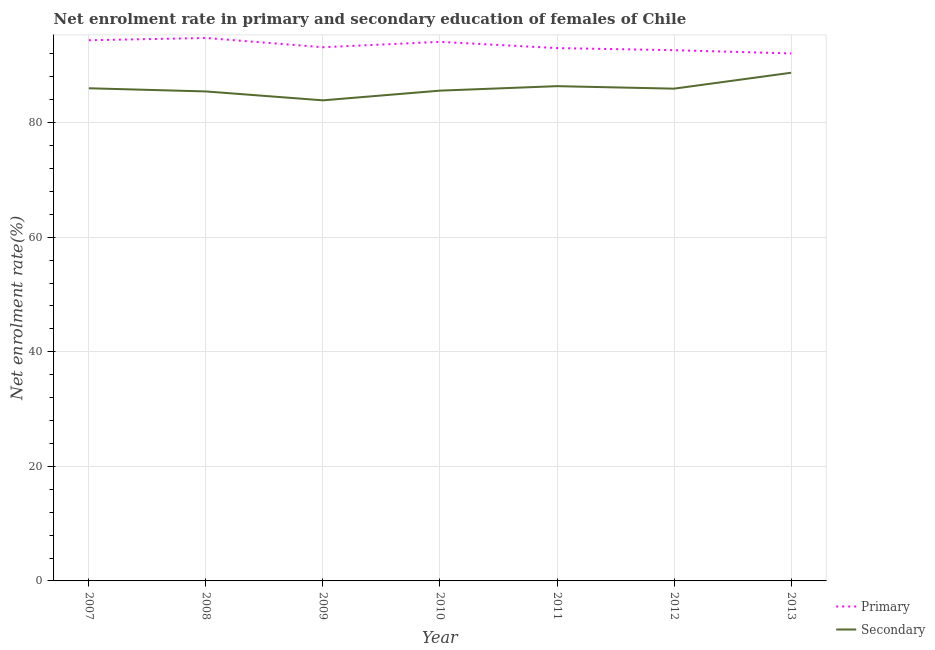Is the number of lines equal to the number of legend labels?
Ensure brevity in your answer.  Yes. What is the enrollment rate in secondary education in 2007?
Ensure brevity in your answer.  86. Across all years, what is the maximum enrollment rate in primary education?
Give a very brief answer. 94.77. Across all years, what is the minimum enrollment rate in primary education?
Provide a short and direct response. 92.08. What is the total enrollment rate in secondary education in the graph?
Your response must be concise. 601.92. What is the difference between the enrollment rate in secondary education in 2011 and that in 2012?
Your answer should be very brief. 0.44. What is the difference between the enrollment rate in secondary education in 2007 and the enrollment rate in primary education in 2013?
Give a very brief answer. -6.08. What is the average enrollment rate in secondary education per year?
Offer a terse response. 85.99. In the year 2013, what is the difference between the enrollment rate in primary education and enrollment rate in secondary education?
Ensure brevity in your answer.  3.37. What is the ratio of the enrollment rate in primary education in 2008 to that in 2012?
Offer a very short reply. 1.02. Is the difference between the enrollment rate in secondary education in 2009 and 2013 greater than the difference between the enrollment rate in primary education in 2009 and 2013?
Your answer should be compact. No. What is the difference between the highest and the second highest enrollment rate in primary education?
Offer a very short reply. 0.39. What is the difference between the highest and the lowest enrollment rate in secondary education?
Provide a short and direct response. 4.82. In how many years, is the enrollment rate in secondary education greater than the average enrollment rate in secondary education taken over all years?
Ensure brevity in your answer.  3. Is the enrollment rate in primary education strictly greater than the enrollment rate in secondary education over the years?
Provide a succinct answer. Yes. How many lines are there?
Offer a terse response. 2. How many years are there in the graph?
Give a very brief answer. 7. Are the values on the major ticks of Y-axis written in scientific E-notation?
Offer a terse response. No. Does the graph contain any zero values?
Make the answer very short. No. What is the title of the graph?
Your response must be concise. Net enrolment rate in primary and secondary education of females of Chile. Does "Registered firms" appear as one of the legend labels in the graph?
Offer a terse response. No. What is the label or title of the X-axis?
Give a very brief answer. Year. What is the label or title of the Y-axis?
Your answer should be very brief. Net enrolment rate(%). What is the Net enrolment rate(%) in Primary in 2007?
Give a very brief answer. 94.38. What is the Net enrolment rate(%) in Secondary in 2007?
Keep it short and to the point. 86. What is the Net enrolment rate(%) of Primary in 2008?
Provide a short and direct response. 94.77. What is the Net enrolment rate(%) of Secondary in 2008?
Your answer should be compact. 85.44. What is the Net enrolment rate(%) in Primary in 2009?
Your response must be concise. 93.16. What is the Net enrolment rate(%) in Secondary in 2009?
Your response must be concise. 83.89. What is the Net enrolment rate(%) of Primary in 2010?
Give a very brief answer. 94.1. What is the Net enrolment rate(%) in Secondary in 2010?
Give a very brief answer. 85.58. What is the Net enrolment rate(%) in Primary in 2011?
Give a very brief answer. 93.01. What is the Net enrolment rate(%) of Secondary in 2011?
Make the answer very short. 86.37. What is the Net enrolment rate(%) in Primary in 2012?
Provide a short and direct response. 92.65. What is the Net enrolment rate(%) in Secondary in 2012?
Ensure brevity in your answer.  85.93. What is the Net enrolment rate(%) of Primary in 2013?
Your answer should be very brief. 92.08. What is the Net enrolment rate(%) in Secondary in 2013?
Your response must be concise. 88.71. Across all years, what is the maximum Net enrolment rate(%) in Primary?
Your answer should be very brief. 94.77. Across all years, what is the maximum Net enrolment rate(%) of Secondary?
Your response must be concise. 88.71. Across all years, what is the minimum Net enrolment rate(%) of Primary?
Your answer should be very brief. 92.08. Across all years, what is the minimum Net enrolment rate(%) in Secondary?
Provide a succinct answer. 83.89. What is the total Net enrolment rate(%) of Primary in the graph?
Provide a succinct answer. 654.16. What is the total Net enrolment rate(%) of Secondary in the graph?
Give a very brief answer. 601.92. What is the difference between the Net enrolment rate(%) in Primary in 2007 and that in 2008?
Your response must be concise. -0.39. What is the difference between the Net enrolment rate(%) of Secondary in 2007 and that in 2008?
Offer a very short reply. 0.55. What is the difference between the Net enrolment rate(%) in Primary in 2007 and that in 2009?
Offer a very short reply. 1.22. What is the difference between the Net enrolment rate(%) in Secondary in 2007 and that in 2009?
Provide a short and direct response. 2.11. What is the difference between the Net enrolment rate(%) of Primary in 2007 and that in 2010?
Your response must be concise. 0.28. What is the difference between the Net enrolment rate(%) of Secondary in 2007 and that in 2010?
Ensure brevity in your answer.  0.41. What is the difference between the Net enrolment rate(%) in Primary in 2007 and that in 2011?
Make the answer very short. 1.37. What is the difference between the Net enrolment rate(%) of Secondary in 2007 and that in 2011?
Offer a terse response. -0.37. What is the difference between the Net enrolment rate(%) in Primary in 2007 and that in 2012?
Offer a very short reply. 1.74. What is the difference between the Net enrolment rate(%) in Secondary in 2007 and that in 2012?
Offer a very short reply. 0.07. What is the difference between the Net enrolment rate(%) in Primary in 2007 and that in 2013?
Your response must be concise. 2.31. What is the difference between the Net enrolment rate(%) in Secondary in 2007 and that in 2013?
Offer a terse response. -2.71. What is the difference between the Net enrolment rate(%) of Primary in 2008 and that in 2009?
Give a very brief answer. 1.61. What is the difference between the Net enrolment rate(%) of Secondary in 2008 and that in 2009?
Make the answer very short. 1.55. What is the difference between the Net enrolment rate(%) of Primary in 2008 and that in 2010?
Your response must be concise. 0.67. What is the difference between the Net enrolment rate(%) of Secondary in 2008 and that in 2010?
Ensure brevity in your answer.  -0.14. What is the difference between the Net enrolment rate(%) in Primary in 2008 and that in 2011?
Give a very brief answer. 1.76. What is the difference between the Net enrolment rate(%) of Secondary in 2008 and that in 2011?
Ensure brevity in your answer.  -0.92. What is the difference between the Net enrolment rate(%) of Primary in 2008 and that in 2012?
Give a very brief answer. 2.13. What is the difference between the Net enrolment rate(%) of Secondary in 2008 and that in 2012?
Your answer should be very brief. -0.49. What is the difference between the Net enrolment rate(%) of Primary in 2008 and that in 2013?
Your answer should be very brief. 2.7. What is the difference between the Net enrolment rate(%) of Secondary in 2008 and that in 2013?
Keep it short and to the point. -3.26. What is the difference between the Net enrolment rate(%) of Primary in 2009 and that in 2010?
Offer a terse response. -0.94. What is the difference between the Net enrolment rate(%) of Secondary in 2009 and that in 2010?
Offer a terse response. -1.69. What is the difference between the Net enrolment rate(%) in Primary in 2009 and that in 2011?
Give a very brief answer. 0.15. What is the difference between the Net enrolment rate(%) in Secondary in 2009 and that in 2011?
Your response must be concise. -2.48. What is the difference between the Net enrolment rate(%) in Primary in 2009 and that in 2012?
Give a very brief answer. 0.51. What is the difference between the Net enrolment rate(%) of Secondary in 2009 and that in 2012?
Ensure brevity in your answer.  -2.04. What is the difference between the Net enrolment rate(%) in Primary in 2009 and that in 2013?
Your response must be concise. 1.08. What is the difference between the Net enrolment rate(%) of Secondary in 2009 and that in 2013?
Your response must be concise. -4.82. What is the difference between the Net enrolment rate(%) of Primary in 2010 and that in 2011?
Provide a short and direct response. 1.09. What is the difference between the Net enrolment rate(%) in Secondary in 2010 and that in 2011?
Your answer should be very brief. -0.78. What is the difference between the Net enrolment rate(%) in Primary in 2010 and that in 2012?
Provide a short and direct response. 1.45. What is the difference between the Net enrolment rate(%) of Secondary in 2010 and that in 2012?
Make the answer very short. -0.35. What is the difference between the Net enrolment rate(%) in Primary in 2010 and that in 2013?
Give a very brief answer. 2.02. What is the difference between the Net enrolment rate(%) in Secondary in 2010 and that in 2013?
Give a very brief answer. -3.12. What is the difference between the Net enrolment rate(%) in Primary in 2011 and that in 2012?
Ensure brevity in your answer.  0.36. What is the difference between the Net enrolment rate(%) in Secondary in 2011 and that in 2012?
Provide a succinct answer. 0.44. What is the difference between the Net enrolment rate(%) in Primary in 2011 and that in 2013?
Provide a short and direct response. 0.93. What is the difference between the Net enrolment rate(%) in Secondary in 2011 and that in 2013?
Offer a terse response. -2.34. What is the difference between the Net enrolment rate(%) of Primary in 2012 and that in 2013?
Your response must be concise. 0.57. What is the difference between the Net enrolment rate(%) of Secondary in 2012 and that in 2013?
Your response must be concise. -2.78. What is the difference between the Net enrolment rate(%) in Primary in 2007 and the Net enrolment rate(%) in Secondary in 2008?
Provide a short and direct response. 8.94. What is the difference between the Net enrolment rate(%) in Primary in 2007 and the Net enrolment rate(%) in Secondary in 2009?
Your answer should be very brief. 10.49. What is the difference between the Net enrolment rate(%) of Primary in 2007 and the Net enrolment rate(%) of Secondary in 2010?
Give a very brief answer. 8.8. What is the difference between the Net enrolment rate(%) in Primary in 2007 and the Net enrolment rate(%) in Secondary in 2011?
Offer a terse response. 8.02. What is the difference between the Net enrolment rate(%) in Primary in 2007 and the Net enrolment rate(%) in Secondary in 2012?
Ensure brevity in your answer.  8.45. What is the difference between the Net enrolment rate(%) of Primary in 2007 and the Net enrolment rate(%) of Secondary in 2013?
Your answer should be compact. 5.68. What is the difference between the Net enrolment rate(%) in Primary in 2008 and the Net enrolment rate(%) in Secondary in 2009?
Ensure brevity in your answer.  10.88. What is the difference between the Net enrolment rate(%) in Primary in 2008 and the Net enrolment rate(%) in Secondary in 2010?
Ensure brevity in your answer.  9.19. What is the difference between the Net enrolment rate(%) of Primary in 2008 and the Net enrolment rate(%) of Secondary in 2011?
Make the answer very short. 8.41. What is the difference between the Net enrolment rate(%) of Primary in 2008 and the Net enrolment rate(%) of Secondary in 2012?
Give a very brief answer. 8.84. What is the difference between the Net enrolment rate(%) of Primary in 2008 and the Net enrolment rate(%) of Secondary in 2013?
Make the answer very short. 6.07. What is the difference between the Net enrolment rate(%) in Primary in 2009 and the Net enrolment rate(%) in Secondary in 2010?
Your answer should be compact. 7.58. What is the difference between the Net enrolment rate(%) in Primary in 2009 and the Net enrolment rate(%) in Secondary in 2011?
Provide a succinct answer. 6.79. What is the difference between the Net enrolment rate(%) in Primary in 2009 and the Net enrolment rate(%) in Secondary in 2012?
Your response must be concise. 7.23. What is the difference between the Net enrolment rate(%) in Primary in 2009 and the Net enrolment rate(%) in Secondary in 2013?
Your answer should be very brief. 4.45. What is the difference between the Net enrolment rate(%) in Primary in 2010 and the Net enrolment rate(%) in Secondary in 2011?
Offer a terse response. 7.73. What is the difference between the Net enrolment rate(%) of Primary in 2010 and the Net enrolment rate(%) of Secondary in 2012?
Keep it short and to the point. 8.17. What is the difference between the Net enrolment rate(%) of Primary in 2010 and the Net enrolment rate(%) of Secondary in 2013?
Give a very brief answer. 5.39. What is the difference between the Net enrolment rate(%) of Primary in 2011 and the Net enrolment rate(%) of Secondary in 2012?
Offer a terse response. 7.08. What is the difference between the Net enrolment rate(%) in Primary in 2011 and the Net enrolment rate(%) in Secondary in 2013?
Keep it short and to the point. 4.3. What is the difference between the Net enrolment rate(%) of Primary in 2012 and the Net enrolment rate(%) of Secondary in 2013?
Offer a terse response. 3.94. What is the average Net enrolment rate(%) of Primary per year?
Make the answer very short. 93.45. What is the average Net enrolment rate(%) of Secondary per year?
Offer a very short reply. 85.99. In the year 2007, what is the difference between the Net enrolment rate(%) in Primary and Net enrolment rate(%) in Secondary?
Your response must be concise. 8.39. In the year 2008, what is the difference between the Net enrolment rate(%) in Primary and Net enrolment rate(%) in Secondary?
Your answer should be compact. 9.33. In the year 2009, what is the difference between the Net enrolment rate(%) of Primary and Net enrolment rate(%) of Secondary?
Provide a short and direct response. 9.27. In the year 2010, what is the difference between the Net enrolment rate(%) in Primary and Net enrolment rate(%) in Secondary?
Ensure brevity in your answer.  8.52. In the year 2011, what is the difference between the Net enrolment rate(%) of Primary and Net enrolment rate(%) of Secondary?
Make the answer very short. 6.64. In the year 2012, what is the difference between the Net enrolment rate(%) in Primary and Net enrolment rate(%) in Secondary?
Your answer should be very brief. 6.72. In the year 2013, what is the difference between the Net enrolment rate(%) of Primary and Net enrolment rate(%) of Secondary?
Offer a very short reply. 3.37. What is the ratio of the Net enrolment rate(%) in Primary in 2007 to that in 2008?
Provide a succinct answer. 1. What is the ratio of the Net enrolment rate(%) of Secondary in 2007 to that in 2008?
Your response must be concise. 1.01. What is the ratio of the Net enrolment rate(%) in Primary in 2007 to that in 2009?
Ensure brevity in your answer.  1.01. What is the ratio of the Net enrolment rate(%) in Secondary in 2007 to that in 2009?
Your response must be concise. 1.03. What is the ratio of the Net enrolment rate(%) of Primary in 2007 to that in 2010?
Offer a terse response. 1. What is the ratio of the Net enrolment rate(%) in Secondary in 2007 to that in 2010?
Offer a very short reply. 1. What is the ratio of the Net enrolment rate(%) of Primary in 2007 to that in 2011?
Your answer should be very brief. 1.01. What is the ratio of the Net enrolment rate(%) in Primary in 2007 to that in 2012?
Provide a short and direct response. 1.02. What is the ratio of the Net enrolment rate(%) in Primary in 2007 to that in 2013?
Offer a very short reply. 1.02. What is the ratio of the Net enrolment rate(%) of Secondary in 2007 to that in 2013?
Offer a very short reply. 0.97. What is the ratio of the Net enrolment rate(%) in Primary in 2008 to that in 2009?
Offer a very short reply. 1.02. What is the ratio of the Net enrolment rate(%) in Secondary in 2008 to that in 2009?
Keep it short and to the point. 1.02. What is the ratio of the Net enrolment rate(%) of Primary in 2008 to that in 2010?
Provide a short and direct response. 1.01. What is the ratio of the Net enrolment rate(%) in Secondary in 2008 to that in 2010?
Ensure brevity in your answer.  1. What is the ratio of the Net enrolment rate(%) in Secondary in 2008 to that in 2011?
Keep it short and to the point. 0.99. What is the ratio of the Net enrolment rate(%) in Secondary in 2008 to that in 2012?
Your answer should be very brief. 0.99. What is the ratio of the Net enrolment rate(%) of Primary in 2008 to that in 2013?
Offer a very short reply. 1.03. What is the ratio of the Net enrolment rate(%) in Secondary in 2008 to that in 2013?
Your answer should be compact. 0.96. What is the ratio of the Net enrolment rate(%) in Primary in 2009 to that in 2010?
Offer a terse response. 0.99. What is the ratio of the Net enrolment rate(%) in Secondary in 2009 to that in 2010?
Ensure brevity in your answer.  0.98. What is the ratio of the Net enrolment rate(%) of Secondary in 2009 to that in 2011?
Give a very brief answer. 0.97. What is the ratio of the Net enrolment rate(%) in Primary in 2009 to that in 2012?
Offer a terse response. 1.01. What is the ratio of the Net enrolment rate(%) of Secondary in 2009 to that in 2012?
Provide a short and direct response. 0.98. What is the ratio of the Net enrolment rate(%) of Primary in 2009 to that in 2013?
Your answer should be very brief. 1.01. What is the ratio of the Net enrolment rate(%) in Secondary in 2009 to that in 2013?
Offer a very short reply. 0.95. What is the ratio of the Net enrolment rate(%) of Primary in 2010 to that in 2011?
Keep it short and to the point. 1.01. What is the ratio of the Net enrolment rate(%) in Secondary in 2010 to that in 2011?
Keep it short and to the point. 0.99. What is the ratio of the Net enrolment rate(%) in Primary in 2010 to that in 2012?
Offer a terse response. 1.02. What is the ratio of the Net enrolment rate(%) of Primary in 2010 to that in 2013?
Your answer should be compact. 1.02. What is the ratio of the Net enrolment rate(%) in Secondary in 2010 to that in 2013?
Provide a short and direct response. 0.96. What is the ratio of the Net enrolment rate(%) of Primary in 2011 to that in 2013?
Give a very brief answer. 1.01. What is the ratio of the Net enrolment rate(%) of Secondary in 2011 to that in 2013?
Your answer should be very brief. 0.97. What is the ratio of the Net enrolment rate(%) in Secondary in 2012 to that in 2013?
Make the answer very short. 0.97. What is the difference between the highest and the second highest Net enrolment rate(%) in Primary?
Your response must be concise. 0.39. What is the difference between the highest and the second highest Net enrolment rate(%) of Secondary?
Your answer should be compact. 2.34. What is the difference between the highest and the lowest Net enrolment rate(%) of Primary?
Provide a succinct answer. 2.7. What is the difference between the highest and the lowest Net enrolment rate(%) of Secondary?
Give a very brief answer. 4.82. 